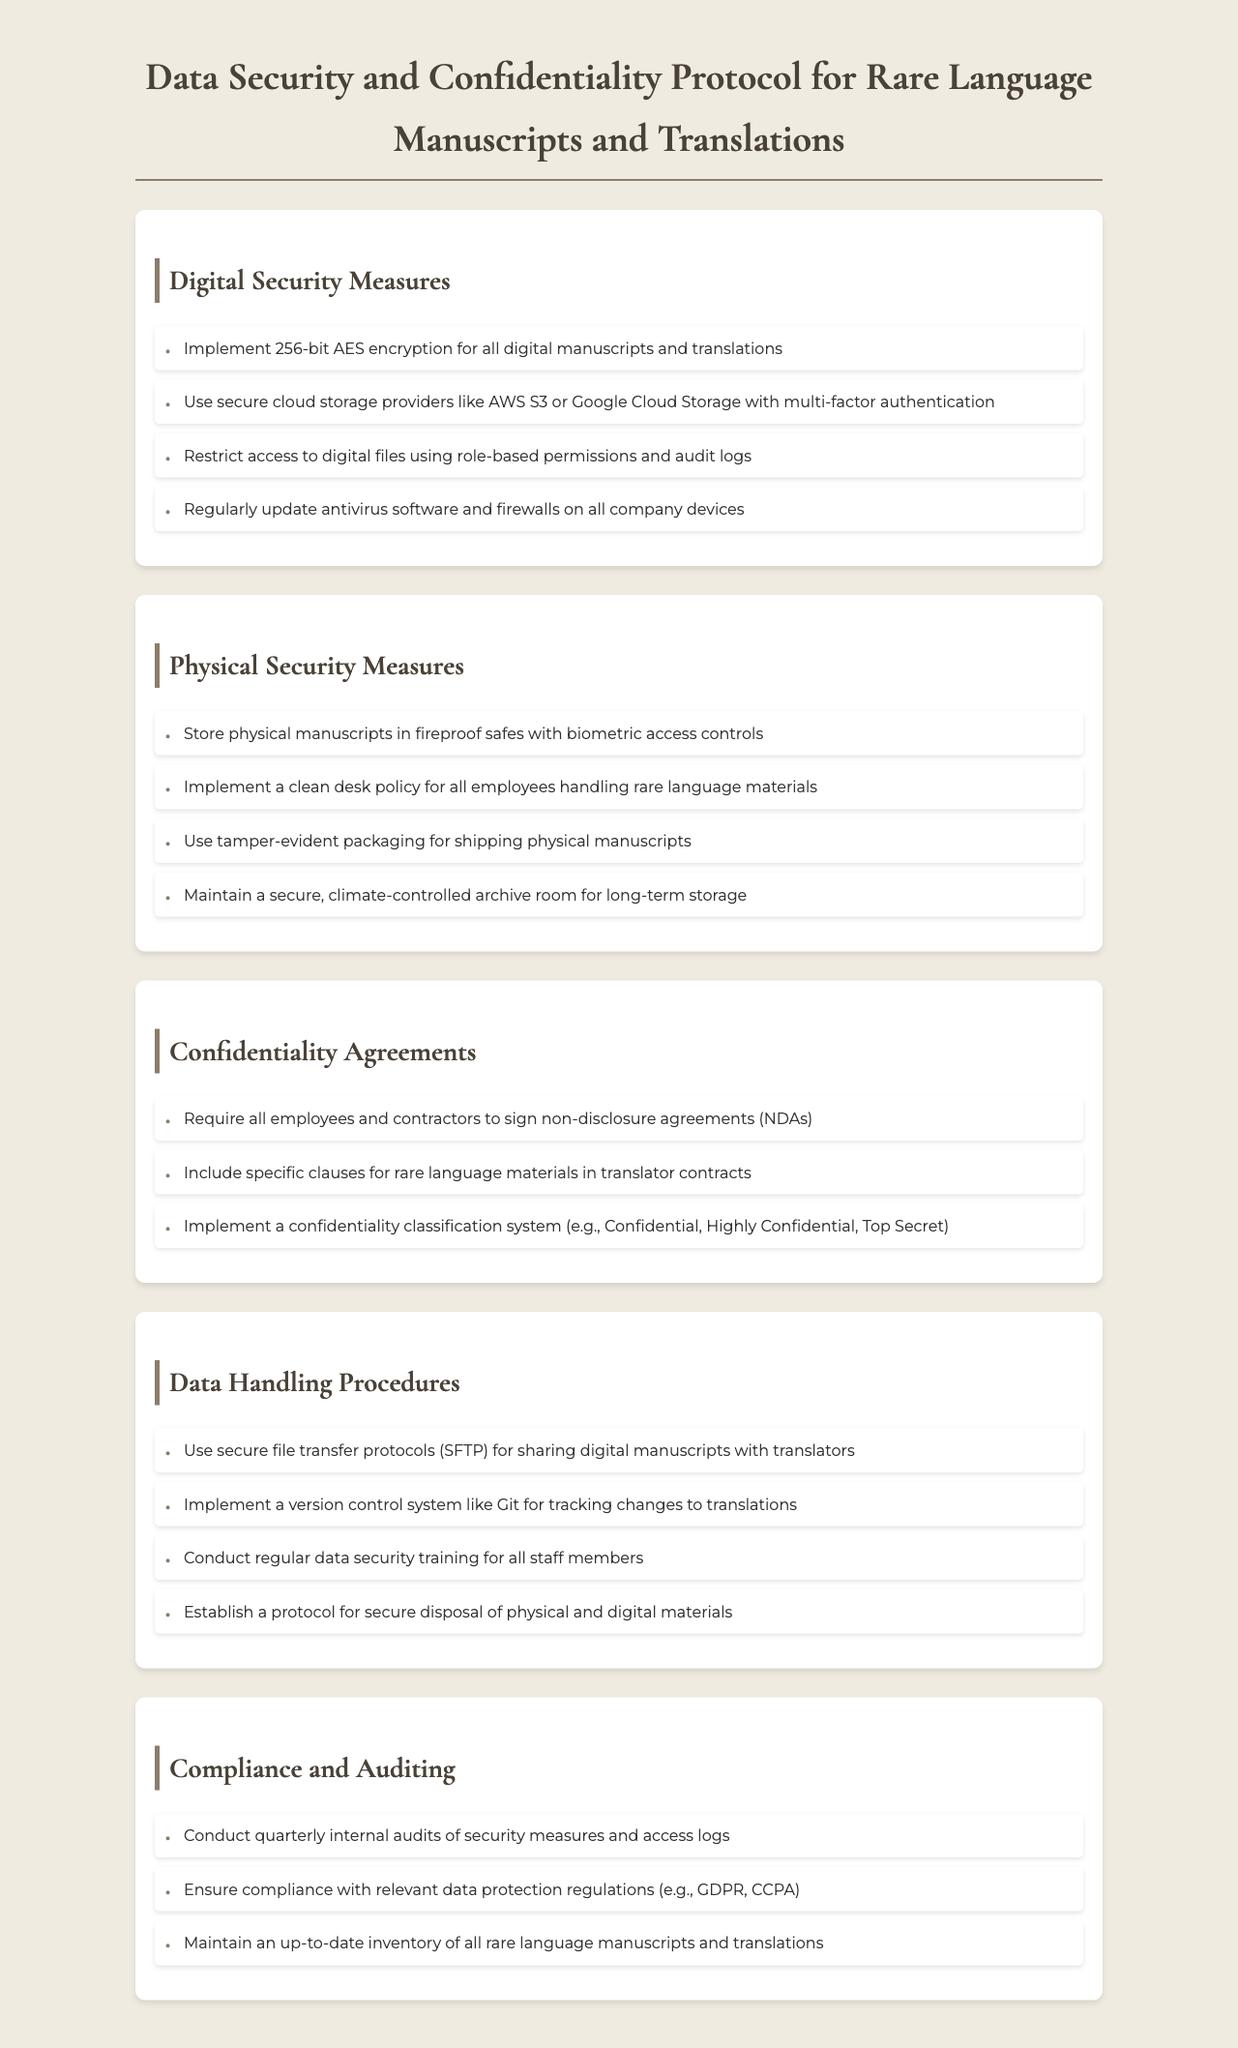what type of encryption is implemented for digital manuscripts? The document specifies the use of 256-bit AES encryption for all digital manuscripts and translations.
Answer: 256-bit AES encryption which cloud storage providers are recommended? The document mentions recommendations for secure cloud storage providers, specifically AWS S3 and Google Cloud Storage.
Answer: AWS S3 or Google Cloud Storage what policy is implemented for employees handling rare language materials? The document refers to the implementation of a clean desk policy for all employees handling rare language materials.
Answer: Clean desk policy how often are internal audits of security measures conducted? The document states that internal audits of security measures and access logs are conducted quarterly.
Answer: Quarterly what is required from all employees and contractors regarding confidentiality? The document indicates that all employees and contractors must sign non-disclosure agreements (NDAs).
Answer: Non-disclosure agreements (NDAs) what system is suggested for transfer of digital manuscripts? The document recommends using secure file transfer protocols (SFTP) for sharing digital manuscripts with translators.
Answer: Secure file transfer protocols (SFTP) how are physical manuscripts secured against unauthorized access? The document states that physical manuscripts are stored in fireproof safes with biometric access controls.
Answer: Fireproof safes with biometric access controls what classification system is mentioned for confidentiality? The document describes a confidentiality classification system, including categories such as Confidential, Highly Confidential, and Top Secret.
Answer: Confidentiality classification system how frequently should data security training be conducted? The document states that regular data security training should be conducted for all staff members.
Answer: Regularly 